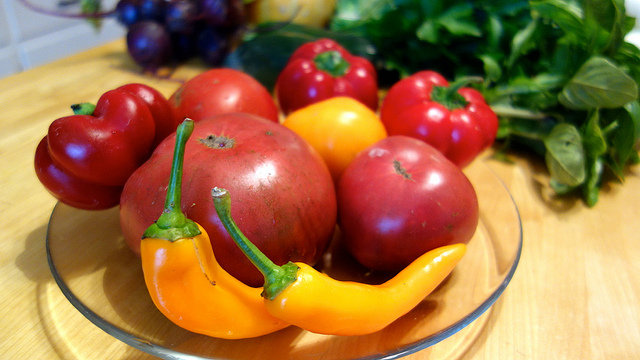How many people are wearing a checked top? The provided image does not depict any people; it shows various fresh vegetables in a bowl. Therefore, it's not possible to count the number of people wearing any type of clothing. 